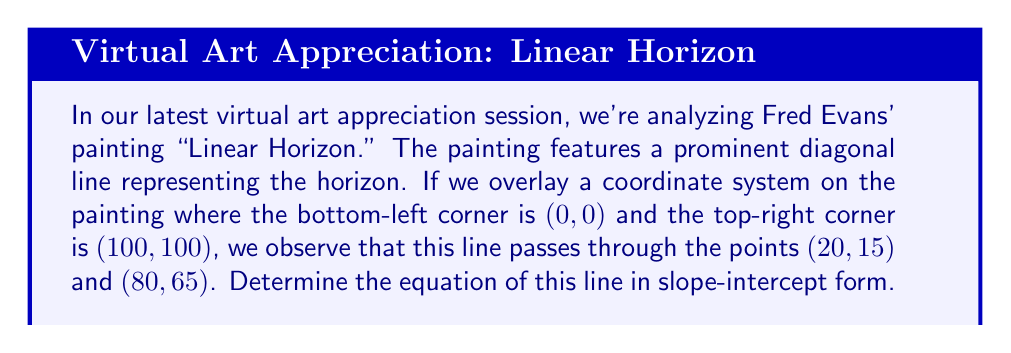Help me with this question. Let's approach this step-by-step:

1) To find the equation of a line in slope-intercept form $(y = mx + b)$, we need to calculate the slope $(m)$ and y-intercept $(b)$.

2) First, let's calculate the slope using the two given points $(20,15)$ and $(80,65)$:

   $m = \frac{y_2 - y_1}{x_2 - x_1} = \frac{65 - 15}{80 - 20} = \frac{50}{60} = \frac{5}{6} \approx 0.8333$

3) Now that we have the slope, we can use either point to find the y-intercept. Let's use $(20,15)$:

   $y = mx + b$
   $15 = \frac{5}{6}(20) + b$
   $15 = \frac{100}{6} + b$
   $b = 15 - \frac{100}{6} = \frac{90 - 100}{6} = -\frac{10}{6} = -\frac{5}{3} \approx -1.6667$

4) Therefore, the equation of the line in slope-intercept form is:

   $y = \frac{5}{6}x - \frac{5}{3}$

5) We can verify this by plugging in the other point $(80,65)$:

   $65 \stackrel{?}{=} \frac{5}{6}(80) - \frac{5}{3}$
   $65 = \frac{400}{6} - \frac{5}{3} = \frac{400}{6} - \frac{10}{6} = \frac{390}{6} = 65$

   This confirms our equation is correct.
Answer: $y = \frac{5}{6}x - \frac{5}{3}$ 